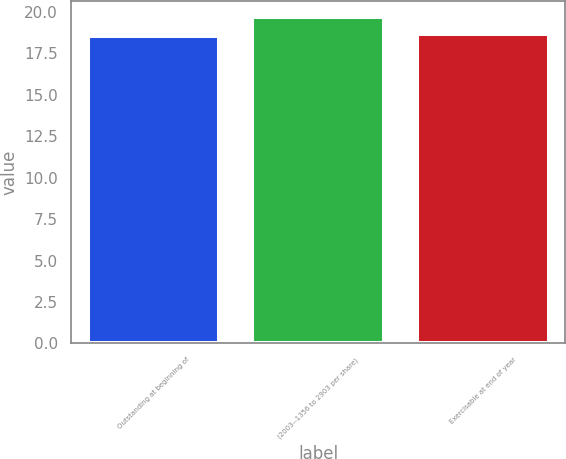Convert chart. <chart><loc_0><loc_0><loc_500><loc_500><bar_chart><fcel>Outstanding at beginning of<fcel>(2003--1356 to 2903 per share)<fcel>Exercisable at end of year<nl><fcel>18.54<fcel>19.67<fcel>18.65<nl></chart> 